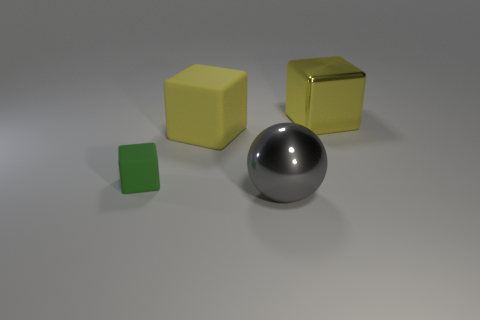Are there any other things that have the same size as the metal ball?
Offer a terse response. Yes. What is the shape of the large shiny thing that is the same color as the big rubber thing?
Give a very brief answer. Cube. There is a thing behind the large matte thing; is its shape the same as the large shiny object to the left of the large metallic cube?
Offer a very short reply. No. Are there any other things that have the same color as the large matte cube?
Your response must be concise. Yes. There is a yellow rubber object; is its size the same as the thing that is behind the yellow matte block?
Keep it short and to the point. Yes. What shape is the big metallic thing in front of the block that is in front of the matte block that is behind the green block?
Make the answer very short. Sphere. Is the number of tiny gray rubber cylinders less than the number of rubber objects?
Ensure brevity in your answer.  Yes. Are there any yellow metal blocks in front of the yellow metallic thing?
Keep it short and to the point. No. The thing that is behind the small green object and left of the gray metallic thing has what shape?
Your answer should be compact. Cube. Are there any other small matte objects of the same shape as the tiny green object?
Ensure brevity in your answer.  No. 